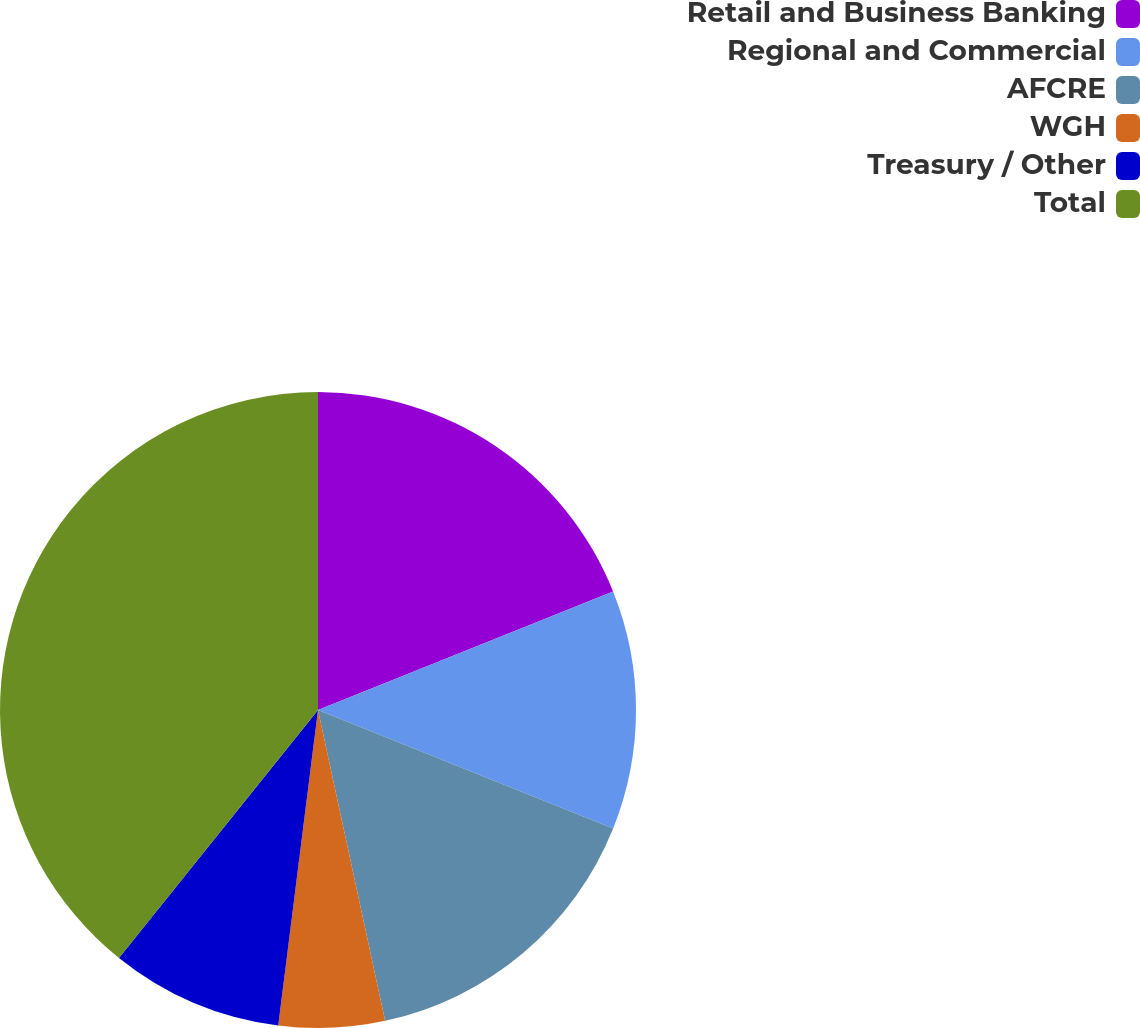<chart> <loc_0><loc_0><loc_500><loc_500><pie_chart><fcel>Retail and Business Banking<fcel>Regional and Commercial<fcel>AFCRE<fcel>WGH<fcel>Treasury / Other<fcel>Total<nl><fcel>18.92%<fcel>12.15%<fcel>15.54%<fcel>5.38%<fcel>8.77%<fcel>39.23%<nl></chart> 